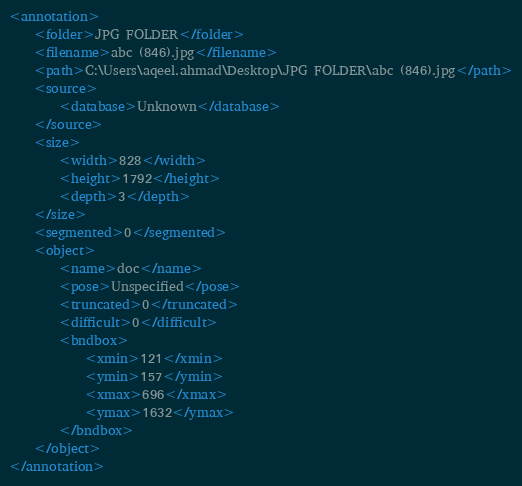Convert code to text. <code><loc_0><loc_0><loc_500><loc_500><_XML_><annotation>
	<folder>JPG FOLDER</folder>
	<filename>abc (846).jpg</filename>
	<path>C:\Users\aqeel.ahmad\Desktop\JPG FOLDER\abc (846).jpg</path>
	<source>
		<database>Unknown</database>
	</source>
	<size>
		<width>828</width>
		<height>1792</height>
		<depth>3</depth>
	</size>
	<segmented>0</segmented>
	<object>
		<name>doc</name>
		<pose>Unspecified</pose>
		<truncated>0</truncated>
		<difficult>0</difficult>
		<bndbox>
			<xmin>121</xmin>
			<ymin>157</ymin>
			<xmax>696</xmax>
			<ymax>1632</ymax>
		</bndbox>
	</object>
</annotation>
</code> 